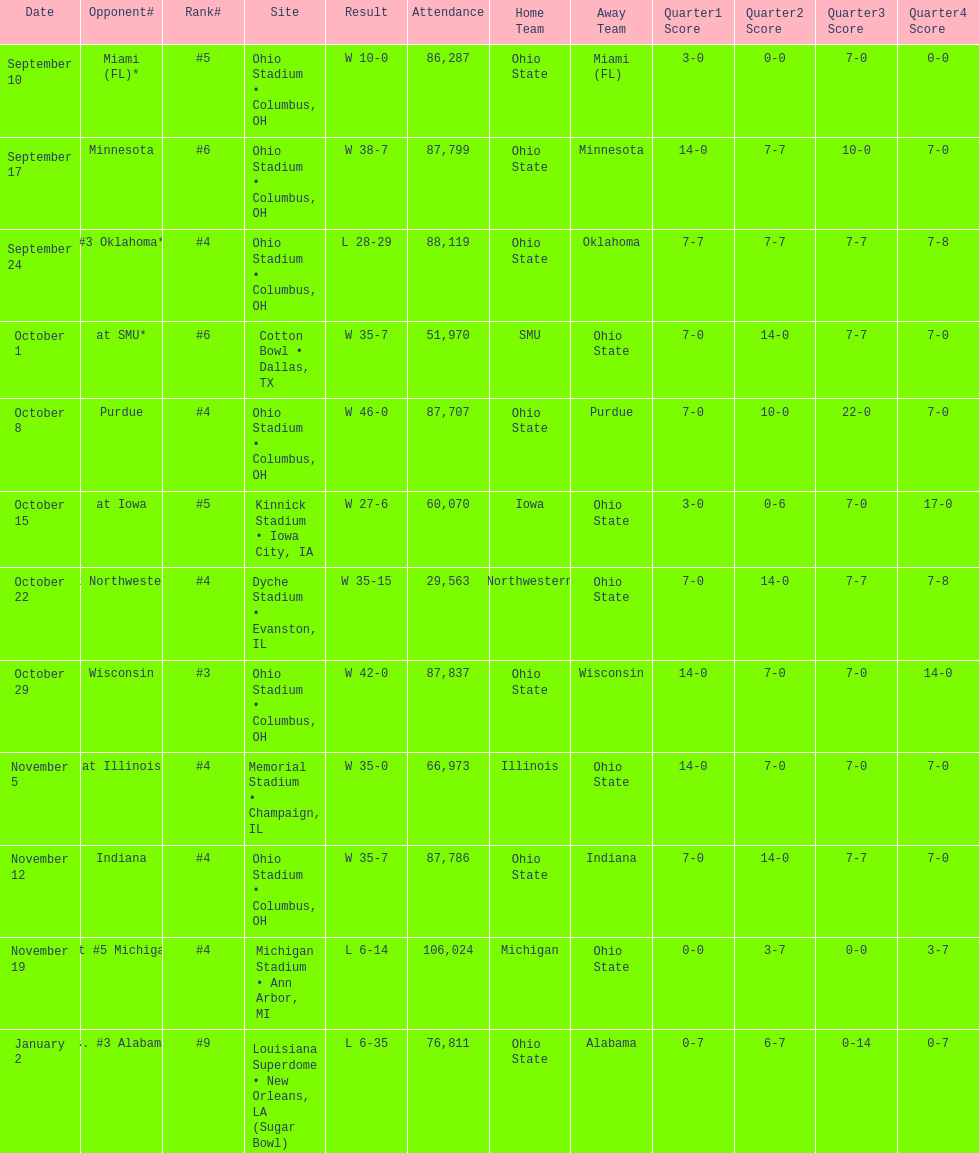How many dates are on the chart 12. 